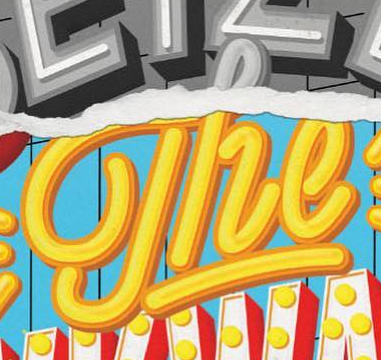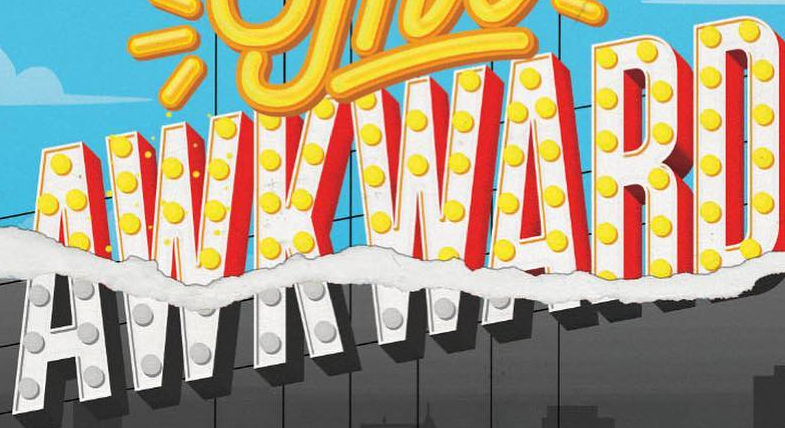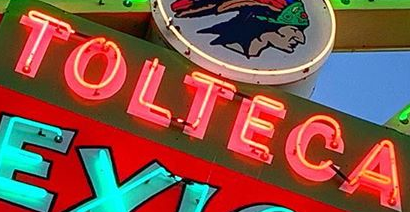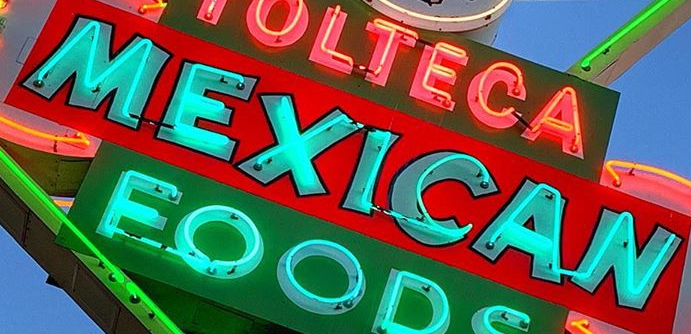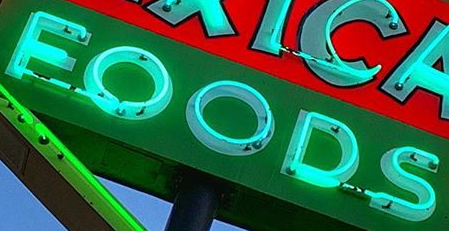Identify the words shown in these images in order, separated by a semicolon. The; AWKWARD; TOLTECA; MEXICAN; FOODS 